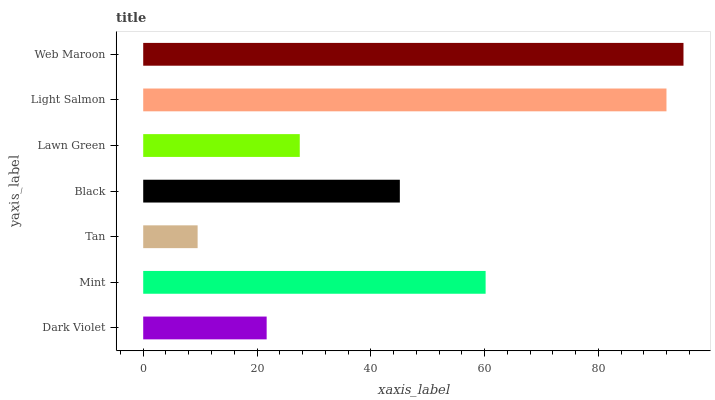Is Tan the minimum?
Answer yes or no. Yes. Is Web Maroon the maximum?
Answer yes or no. Yes. Is Mint the minimum?
Answer yes or no. No. Is Mint the maximum?
Answer yes or no. No. Is Mint greater than Dark Violet?
Answer yes or no. Yes. Is Dark Violet less than Mint?
Answer yes or no. Yes. Is Dark Violet greater than Mint?
Answer yes or no. No. Is Mint less than Dark Violet?
Answer yes or no. No. Is Black the high median?
Answer yes or no. Yes. Is Black the low median?
Answer yes or no. Yes. Is Mint the high median?
Answer yes or no. No. Is Mint the low median?
Answer yes or no. No. 